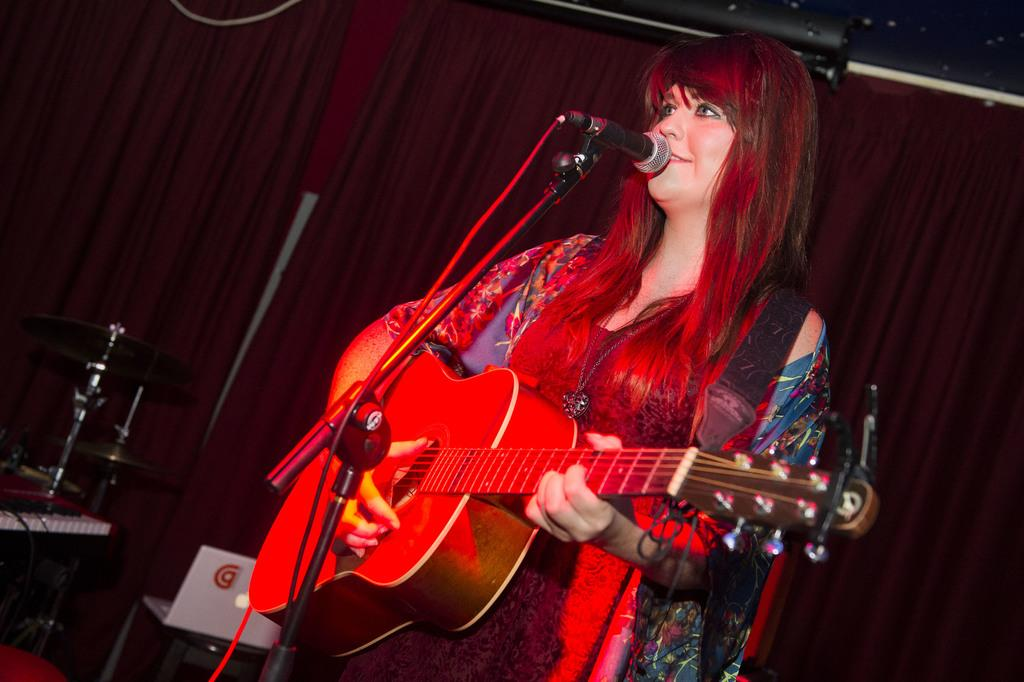Who is the main subject in the image? There is a woman in the image. What is the woman doing in the image? The woman is standing in front of a mic and holding a guitar. What is the woman's facial expression in the image? The woman is smiling in the image. What can be seen in the background of the image? There is a chair and a red color curtain in the background of the image. What type of slip can be seen on the floor in the image? There is no slip present on the floor in the image. What type of cart is being used to transport the woman's equipment in the image? There is no cart present in the image; the woman is holding a guitar and standing in front of a mic. 